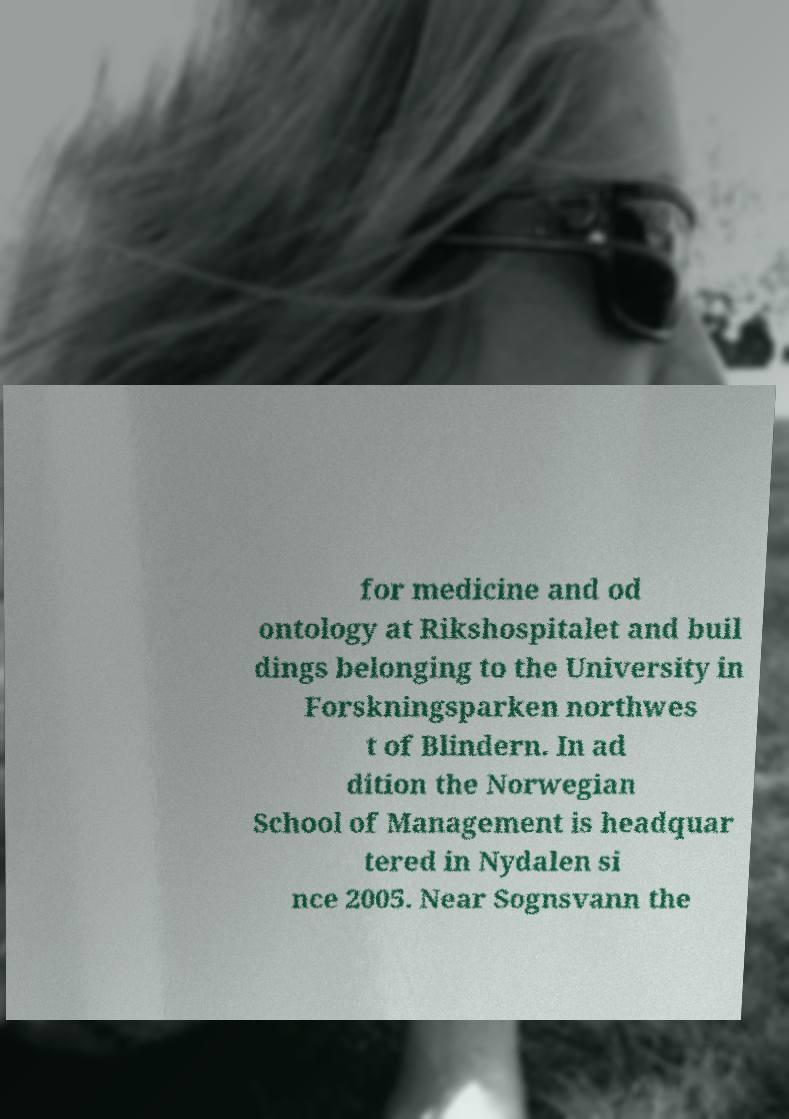There's text embedded in this image that I need extracted. Can you transcribe it verbatim? for medicine and od ontology at Rikshospitalet and buil dings belonging to the University in Forskningsparken northwes t of Blindern. In ad dition the Norwegian School of Management is headquar tered in Nydalen si nce 2005. Near Sognsvann the 